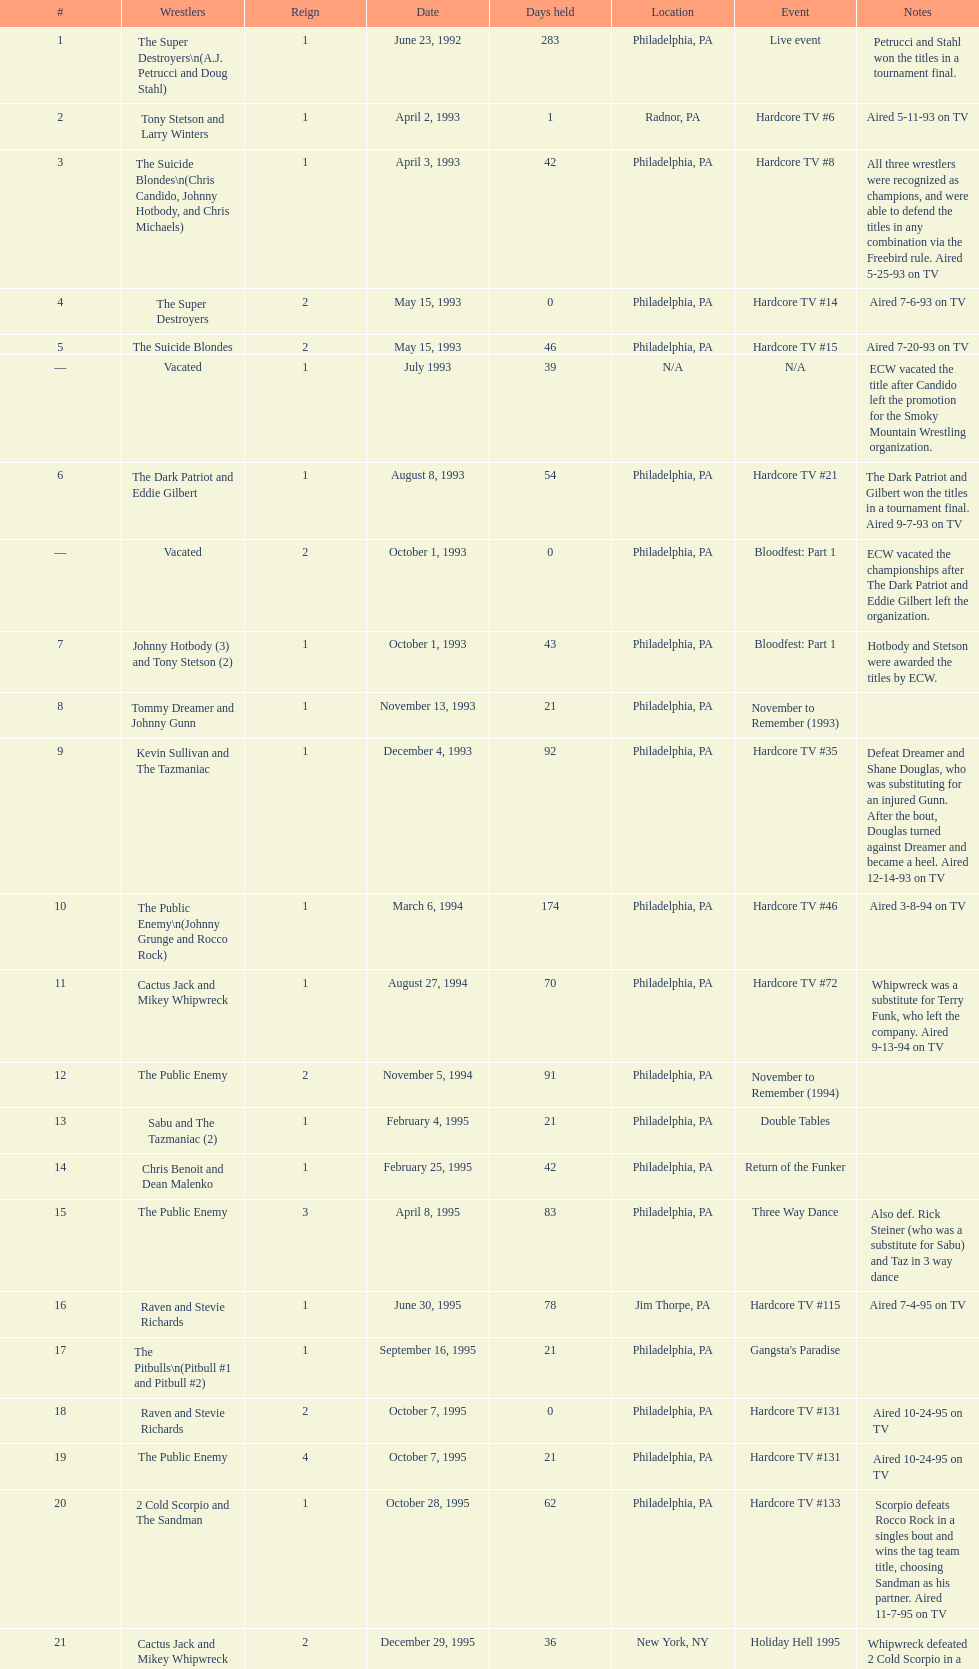Before public enemy recaptured the title on april 8th, 1995, who was the holder? Chris Benoit and Dean Malenko. 